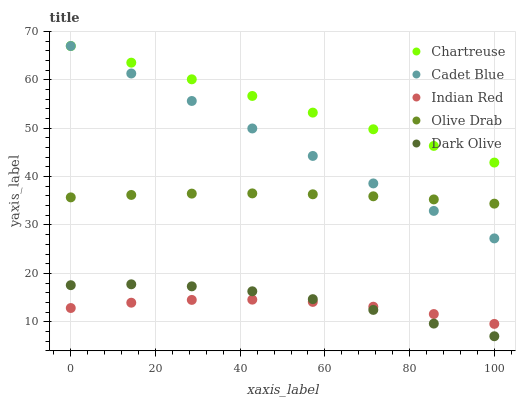Does Indian Red have the minimum area under the curve?
Answer yes or no. Yes. Does Chartreuse have the maximum area under the curve?
Answer yes or no. Yes. Does Cadet Blue have the minimum area under the curve?
Answer yes or no. No. Does Cadet Blue have the maximum area under the curve?
Answer yes or no. No. Is Cadet Blue the smoothest?
Answer yes or no. Yes. Is Dark Olive the roughest?
Answer yes or no. Yes. Is Chartreuse the smoothest?
Answer yes or no. No. Is Chartreuse the roughest?
Answer yes or no. No. Does Dark Olive have the lowest value?
Answer yes or no. Yes. Does Cadet Blue have the lowest value?
Answer yes or no. No. Does Cadet Blue have the highest value?
Answer yes or no. Yes. Does Olive Drab have the highest value?
Answer yes or no. No. Is Dark Olive less than Olive Drab?
Answer yes or no. Yes. Is Olive Drab greater than Dark Olive?
Answer yes or no. Yes. Does Cadet Blue intersect Olive Drab?
Answer yes or no. Yes. Is Cadet Blue less than Olive Drab?
Answer yes or no. No. Is Cadet Blue greater than Olive Drab?
Answer yes or no. No. Does Dark Olive intersect Olive Drab?
Answer yes or no. No. 